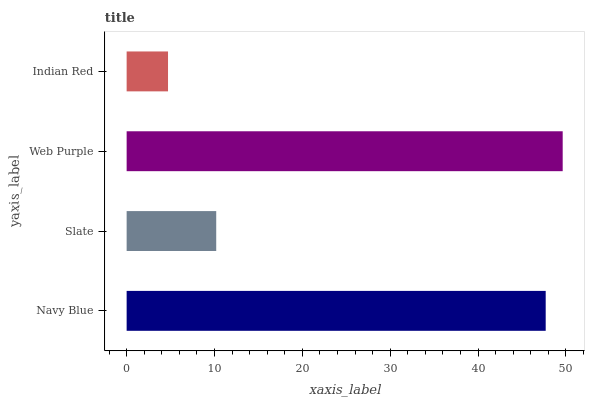Is Indian Red the minimum?
Answer yes or no. Yes. Is Web Purple the maximum?
Answer yes or no. Yes. Is Slate the minimum?
Answer yes or no. No. Is Slate the maximum?
Answer yes or no. No. Is Navy Blue greater than Slate?
Answer yes or no. Yes. Is Slate less than Navy Blue?
Answer yes or no. Yes. Is Slate greater than Navy Blue?
Answer yes or no. No. Is Navy Blue less than Slate?
Answer yes or no. No. Is Navy Blue the high median?
Answer yes or no. Yes. Is Slate the low median?
Answer yes or no. Yes. Is Web Purple the high median?
Answer yes or no. No. Is Web Purple the low median?
Answer yes or no. No. 